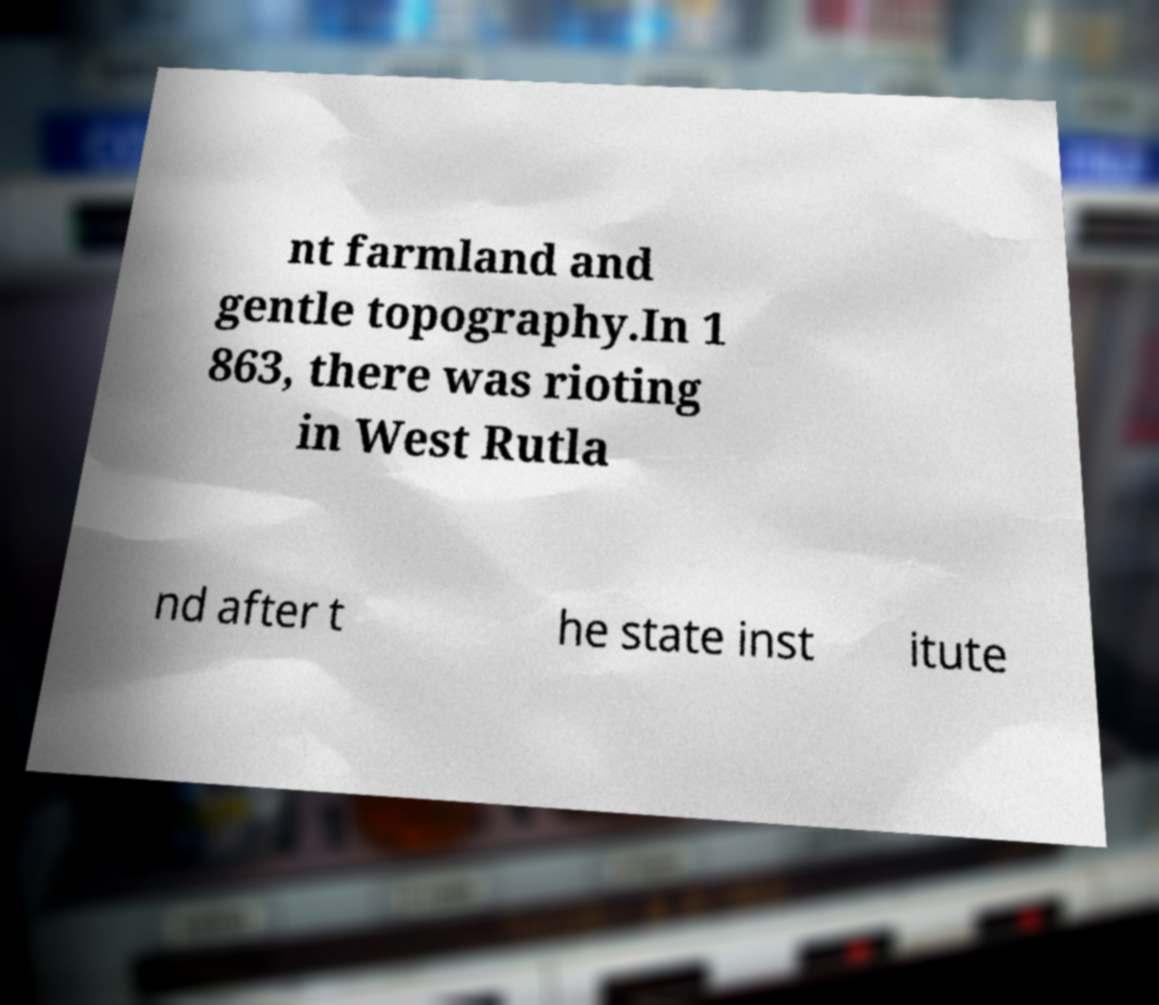Could you extract and type out the text from this image? nt farmland and gentle topography.In 1 863, there was rioting in West Rutla nd after t he state inst itute 